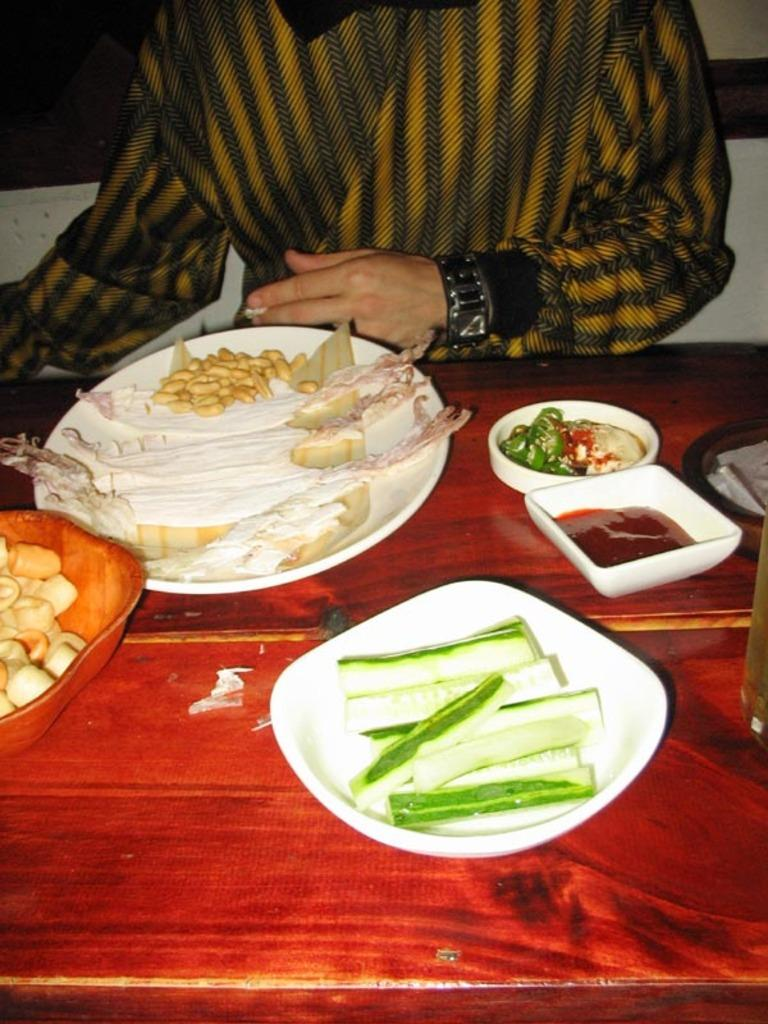What is the person in the image doing? The person is sitting in front of a table. What objects are on the table? Plates and bowls are placed on the table. What is inside the plates and bowls? There is food in the plates and bowls. How does the person stretch their arms in the image? There is no indication in the image that the person is stretching their arms. 